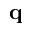<formula> <loc_0><loc_0><loc_500><loc_500>\mathbf q</formula> 